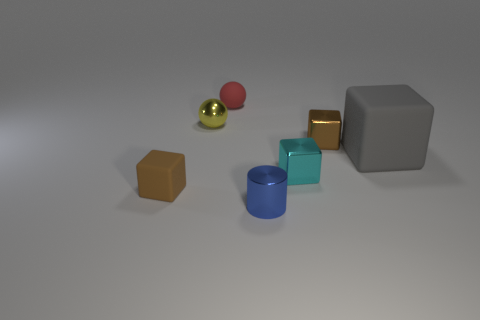Subtract 1 cubes. How many cubes are left? 3 Add 2 tiny red spheres. How many objects exist? 9 Subtract all balls. How many objects are left? 5 Add 4 brown metallic blocks. How many brown metallic blocks exist? 5 Subtract 0 blue blocks. How many objects are left? 7 Subtract all big red matte cylinders. Subtract all small blue cylinders. How many objects are left? 6 Add 5 red objects. How many red objects are left? 6 